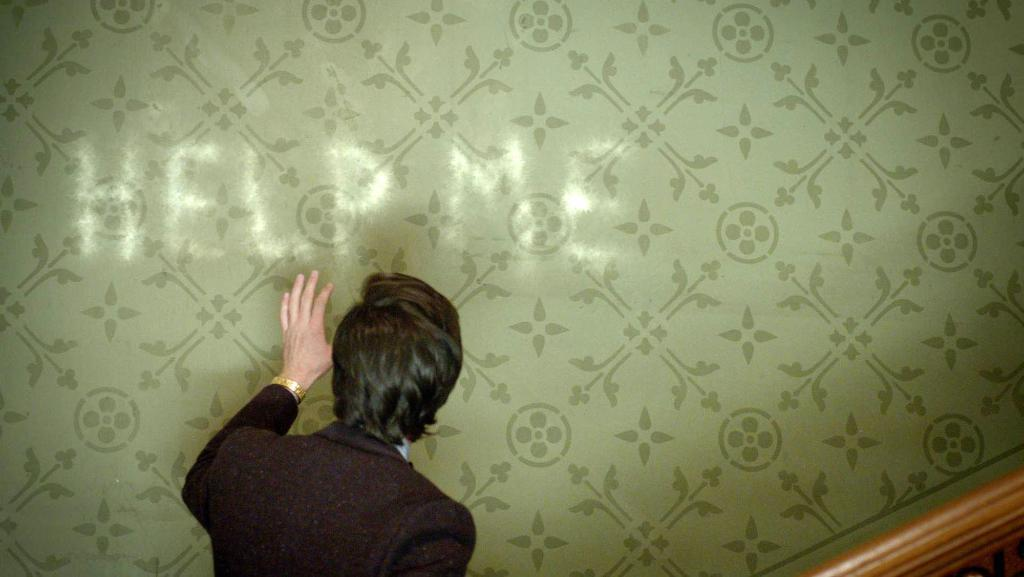What is the main subject of the image? There is a person in the image. What is the person wearing? The person is wearing a black suit and a bracelet. What is the person doing in the image? The person's hand is on a designed sheet. What can be read on the sheet? The sheet has the text "help me" written on it. What type of bird can be seen flying over the person in the image? There is no bird visible in the image. How does the ice help the person in the image? There is no ice present in the image, and therefore it cannot help the person. 